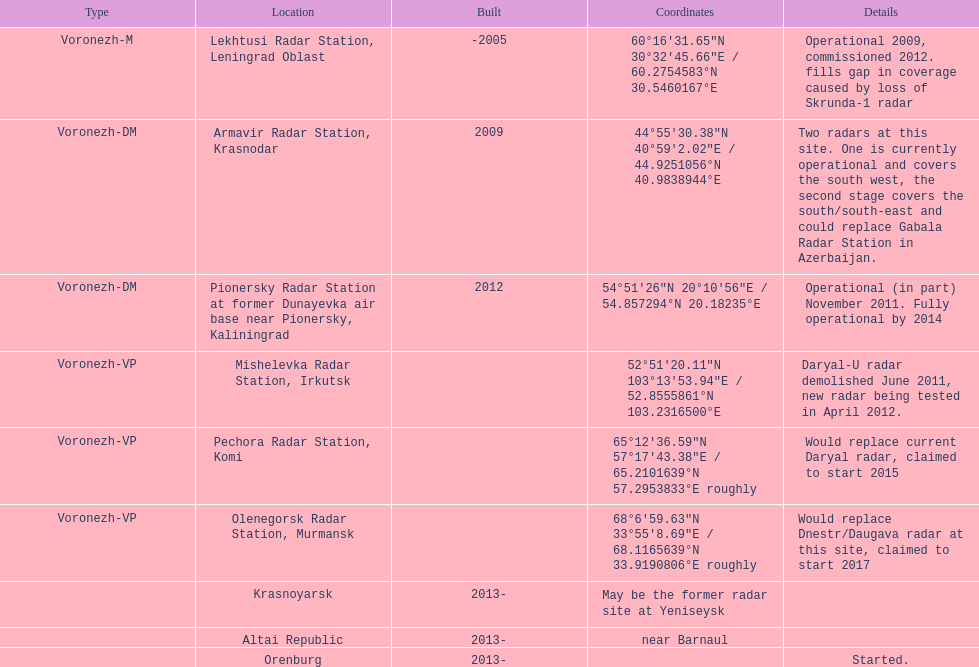What is the only location with a coordination of 60°16&#8242;31.65&#8243;n 30°32&#8242;45.66&#8243;e / 60.2754583°n 30.5460167°e? Lekhtusi Radar Station, Leningrad Oblast. 